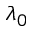<formula> <loc_0><loc_0><loc_500><loc_500>\lambda _ { 0 }</formula> 